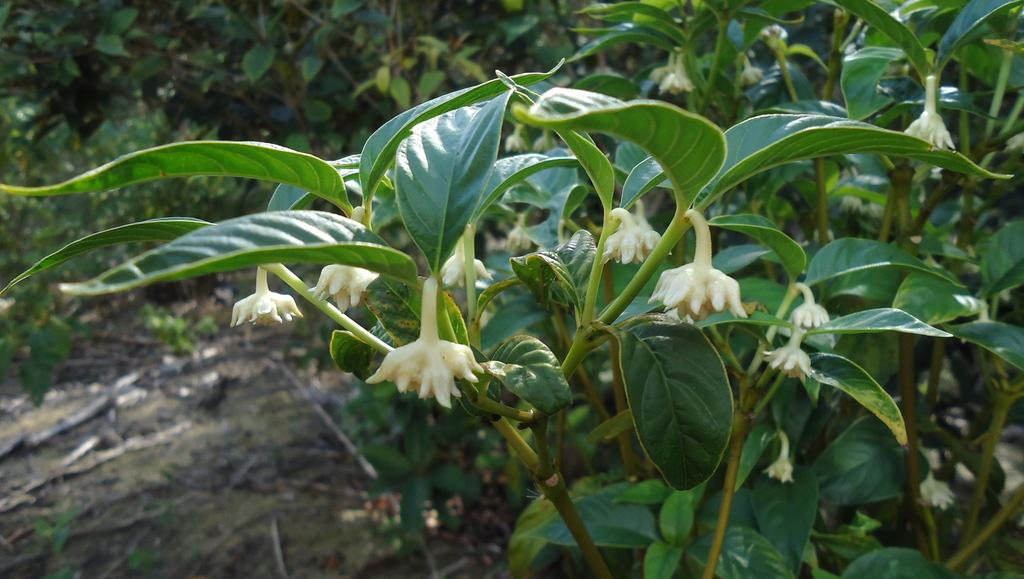What is the main subject of the picture? The main subject of the picture is a plant. What specific feature can be observed on the plant? The plant has flowers. What can be seen in the background of the picture? There are trees in the background of the picture. What is present on the ground in the image? Soil is present on the ground. What type of authority is depicted in the image? There is no authority figure present in the image; it features a plant with flowers, trees in the background, and soil on the ground. What decision is being made in the image? There is no decision-making process depicted in the image; it is a still image of a plant with flowers, trees in the background, and soil on the ground. 